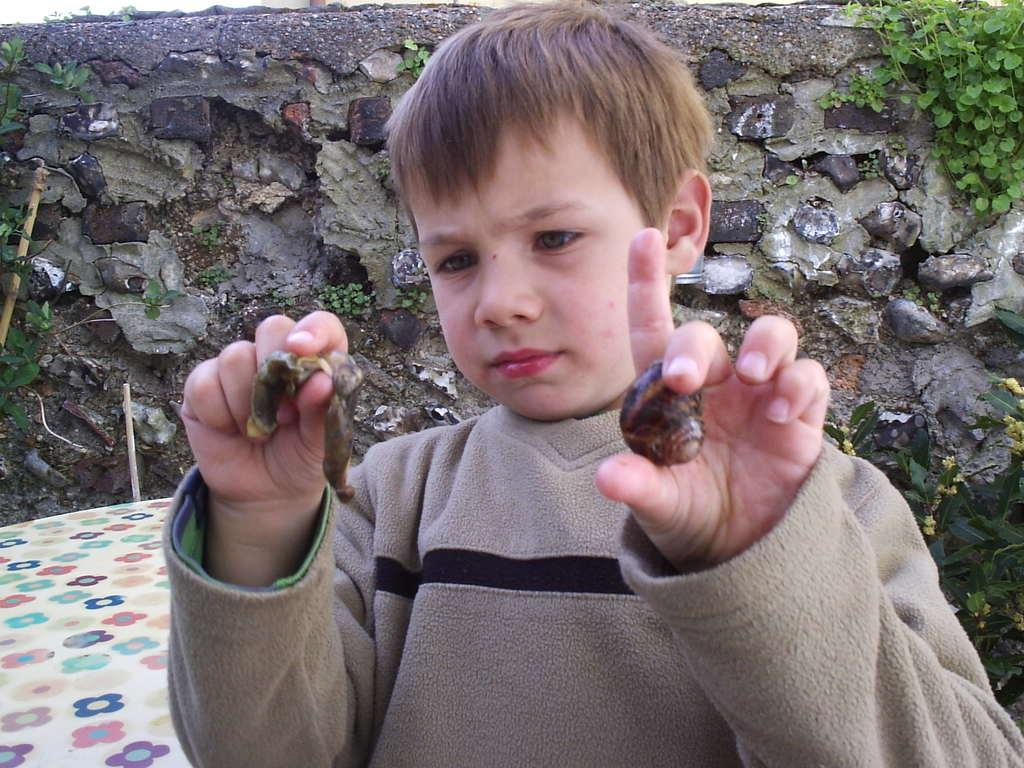What is the main subject of the image? The main subject of the image is a kid. What is the kid holding in one hand? The kid is holding an insect in one hand. What is the kid holding in the other hand? The kid is holding a snail shell in the other hand. What can be seen in the background of the image? There is a stone wall in the background of the image. What type of iron gate can be seen in the image? There is no iron gate present in the image. 